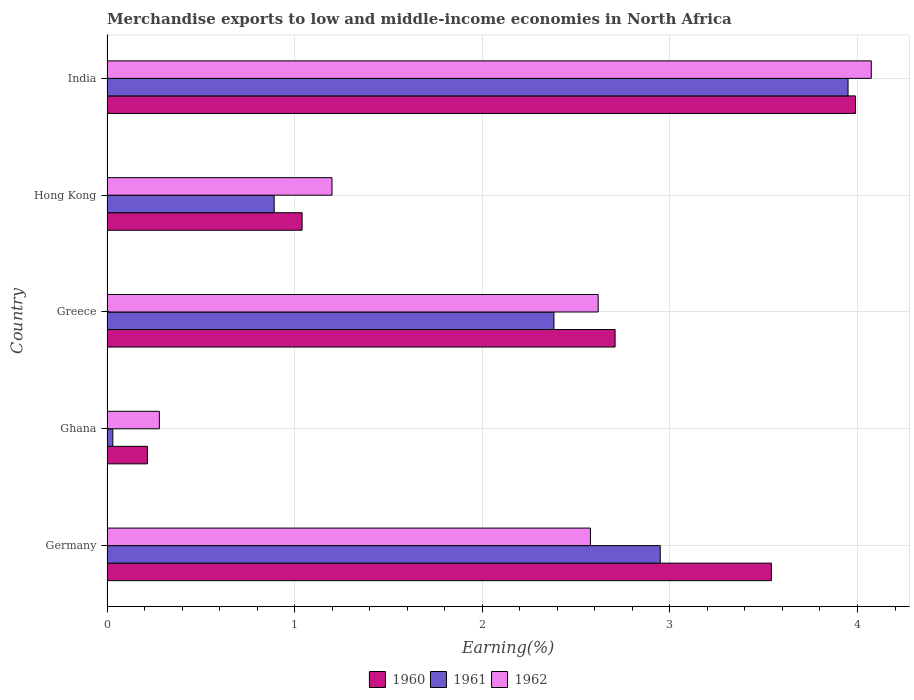How many different coloured bars are there?
Offer a very short reply. 3. What is the percentage of amount earned from merchandise exports in 1962 in India?
Ensure brevity in your answer.  4.07. Across all countries, what is the maximum percentage of amount earned from merchandise exports in 1960?
Keep it short and to the point. 3.99. Across all countries, what is the minimum percentage of amount earned from merchandise exports in 1960?
Make the answer very short. 0.22. In which country was the percentage of amount earned from merchandise exports in 1962 maximum?
Your response must be concise. India. In which country was the percentage of amount earned from merchandise exports in 1961 minimum?
Your answer should be compact. Ghana. What is the total percentage of amount earned from merchandise exports in 1961 in the graph?
Make the answer very short. 10.2. What is the difference between the percentage of amount earned from merchandise exports in 1960 in Germany and that in Greece?
Provide a short and direct response. 0.83. What is the difference between the percentage of amount earned from merchandise exports in 1960 in Greece and the percentage of amount earned from merchandise exports in 1961 in India?
Offer a terse response. -1.24. What is the average percentage of amount earned from merchandise exports in 1962 per country?
Your answer should be compact. 2.15. What is the difference between the percentage of amount earned from merchandise exports in 1960 and percentage of amount earned from merchandise exports in 1962 in Greece?
Your answer should be compact. 0.09. What is the ratio of the percentage of amount earned from merchandise exports in 1960 in Ghana to that in Greece?
Give a very brief answer. 0.08. What is the difference between the highest and the second highest percentage of amount earned from merchandise exports in 1960?
Make the answer very short. 0.45. What is the difference between the highest and the lowest percentage of amount earned from merchandise exports in 1961?
Make the answer very short. 3.92. Is the sum of the percentage of amount earned from merchandise exports in 1962 in Ghana and Greece greater than the maximum percentage of amount earned from merchandise exports in 1960 across all countries?
Make the answer very short. No. Are all the bars in the graph horizontal?
Make the answer very short. Yes. What is the difference between two consecutive major ticks on the X-axis?
Your response must be concise. 1. Are the values on the major ticks of X-axis written in scientific E-notation?
Provide a succinct answer. No. Where does the legend appear in the graph?
Your answer should be compact. Bottom center. How many legend labels are there?
Your answer should be compact. 3. How are the legend labels stacked?
Offer a very short reply. Horizontal. What is the title of the graph?
Give a very brief answer. Merchandise exports to low and middle-income economies in North Africa. What is the label or title of the X-axis?
Your response must be concise. Earning(%). What is the label or title of the Y-axis?
Make the answer very short. Country. What is the Earning(%) of 1960 in Germany?
Ensure brevity in your answer.  3.54. What is the Earning(%) of 1961 in Germany?
Keep it short and to the point. 2.95. What is the Earning(%) of 1962 in Germany?
Provide a short and direct response. 2.58. What is the Earning(%) in 1960 in Ghana?
Ensure brevity in your answer.  0.22. What is the Earning(%) of 1961 in Ghana?
Offer a terse response. 0.03. What is the Earning(%) of 1962 in Ghana?
Make the answer very short. 0.28. What is the Earning(%) in 1960 in Greece?
Ensure brevity in your answer.  2.71. What is the Earning(%) in 1961 in Greece?
Give a very brief answer. 2.38. What is the Earning(%) of 1962 in Greece?
Offer a very short reply. 2.62. What is the Earning(%) in 1960 in Hong Kong?
Provide a short and direct response. 1.04. What is the Earning(%) in 1961 in Hong Kong?
Offer a very short reply. 0.89. What is the Earning(%) of 1962 in Hong Kong?
Keep it short and to the point. 1.2. What is the Earning(%) in 1960 in India?
Your answer should be compact. 3.99. What is the Earning(%) of 1961 in India?
Your response must be concise. 3.95. What is the Earning(%) in 1962 in India?
Provide a short and direct response. 4.07. Across all countries, what is the maximum Earning(%) of 1960?
Ensure brevity in your answer.  3.99. Across all countries, what is the maximum Earning(%) in 1961?
Provide a succinct answer. 3.95. Across all countries, what is the maximum Earning(%) of 1962?
Offer a terse response. 4.07. Across all countries, what is the minimum Earning(%) of 1960?
Give a very brief answer. 0.22. Across all countries, what is the minimum Earning(%) of 1961?
Keep it short and to the point. 0.03. Across all countries, what is the minimum Earning(%) in 1962?
Give a very brief answer. 0.28. What is the total Earning(%) in 1960 in the graph?
Offer a very short reply. 11.49. What is the total Earning(%) of 1961 in the graph?
Your answer should be very brief. 10.2. What is the total Earning(%) in 1962 in the graph?
Offer a terse response. 10.75. What is the difference between the Earning(%) in 1960 in Germany and that in Ghana?
Offer a terse response. 3.33. What is the difference between the Earning(%) in 1961 in Germany and that in Ghana?
Provide a short and direct response. 2.92. What is the difference between the Earning(%) in 1962 in Germany and that in Ghana?
Keep it short and to the point. 2.3. What is the difference between the Earning(%) in 1960 in Germany and that in Greece?
Your answer should be very brief. 0.83. What is the difference between the Earning(%) of 1961 in Germany and that in Greece?
Provide a short and direct response. 0.57. What is the difference between the Earning(%) in 1962 in Germany and that in Greece?
Provide a succinct answer. -0.04. What is the difference between the Earning(%) in 1960 in Germany and that in Hong Kong?
Offer a terse response. 2.5. What is the difference between the Earning(%) in 1961 in Germany and that in Hong Kong?
Your response must be concise. 2.06. What is the difference between the Earning(%) in 1962 in Germany and that in Hong Kong?
Make the answer very short. 1.38. What is the difference between the Earning(%) of 1960 in Germany and that in India?
Offer a very short reply. -0.45. What is the difference between the Earning(%) in 1961 in Germany and that in India?
Make the answer very short. -1. What is the difference between the Earning(%) of 1962 in Germany and that in India?
Your answer should be very brief. -1.5. What is the difference between the Earning(%) of 1960 in Ghana and that in Greece?
Offer a terse response. -2.49. What is the difference between the Earning(%) in 1961 in Ghana and that in Greece?
Keep it short and to the point. -2.35. What is the difference between the Earning(%) in 1962 in Ghana and that in Greece?
Offer a very short reply. -2.34. What is the difference between the Earning(%) in 1960 in Ghana and that in Hong Kong?
Provide a short and direct response. -0.82. What is the difference between the Earning(%) of 1961 in Ghana and that in Hong Kong?
Your answer should be very brief. -0.86. What is the difference between the Earning(%) of 1962 in Ghana and that in Hong Kong?
Make the answer very short. -0.92. What is the difference between the Earning(%) of 1960 in Ghana and that in India?
Give a very brief answer. -3.77. What is the difference between the Earning(%) of 1961 in Ghana and that in India?
Provide a succinct answer. -3.92. What is the difference between the Earning(%) of 1962 in Ghana and that in India?
Provide a succinct answer. -3.79. What is the difference between the Earning(%) of 1960 in Greece and that in Hong Kong?
Make the answer very short. 1.67. What is the difference between the Earning(%) of 1961 in Greece and that in Hong Kong?
Your response must be concise. 1.49. What is the difference between the Earning(%) of 1962 in Greece and that in Hong Kong?
Offer a terse response. 1.42. What is the difference between the Earning(%) in 1960 in Greece and that in India?
Offer a very short reply. -1.28. What is the difference between the Earning(%) of 1961 in Greece and that in India?
Provide a short and direct response. -1.57. What is the difference between the Earning(%) in 1962 in Greece and that in India?
Your response must be concise. -1.46. What is the difference between the Earning(%) of 1960 in Hong Kong and that in India?
Your answer should be very brief. -2.95. What is the difference between the Earning(%) of 1961 in Hong Kong and that in India?
Your answer should be compact. -3.06. What is the difference between the Earning(%) in 1962 in Hong Kong and that in India?
Offer a terse response. -2.87. What is the difference between the Earning(%) of 1960 in Germany and the Earning(%) of 1961 in Ghana?
Your answer should be compact. 3.51. What is the difference between the Earning(%) of 1960 in Germany and the Earning(%) of 1962 in Ghana?
Ensure brevity in your answer.  3.26. What is the difference between the Earning(%) of 1961 in Germany and the Earning(%) of 1962 in Ghana?
Offer a terse response. 2.67. What is the difference between the Earning(%) in 1960 in Germany and the Earning(%) in 1961 in Greece?
Make the answer very short. 1.16. What is the difference between the Earning(%) in 1960 in Germany and the Earning(%) in 1962 in Greece?
Offer a very short reply. 0.92. What is the difference between the Earning(%) of 1961 in Germany and the Earning(%) of 1962 in Greece?
Make the answer very short. 0.33. What is the difference between the Earning(%) of 1960 in Germany and the Earning(%) of 1961 in Hong Kong?
Make the answer very short. 2.65. What is the difference between the Earning(%) of 1960 in Germany and the Earning(%) of 1962 in Hong Kong?
Provide a succinct answer. 2.34. What is the difference between the Earning(%) of 1961 in Germany and the Earning(%) of 1962 in Hong Kong?
Your answer should be very brief. 1.75. What is the difference between the Earning(%) of 1960 in Germany and the Earning(%) of 1961 in India?
Your response must be concise. -0.41. What is the difference between the Earning(%) in 1960 in Germany and the Earning(%) in 1962 in India?
Offer a terse response. -0.53. What is the difference between the Earning(%) in 1961 in Germany and the Earning(%) in 1962 in India?
Keep it short and to the point. -1.12. What is the difference between the Earning(%) of 1960 in Ghana and the Earning(%) of 1961 in Greece?
Keep it short and to the point. -2.17. What is the difference between the Earning(%) in 1960 in Ghana and the Earning(%) in 1962 in Greece?
Offer a very short reply. -2.4. What is the difference between the Earning(%) in 1961 in Ghana and the Earning(%) in 1962 in Greece?
Provide a short and direct response. -2.59. What is the difference between the Earning(%) of 1960 in Ghana and the Earning(%) of 1961 in Hong Kong?
Your answer should be compact. -0.68. What is the difference between the Earning(%) of 1960 in Ghana and the Earning(%) of 1962 in Hong Kong?
Provide a succinct answer. -0.98. What is the difference between the Earning(%) in 1961 in Ghana and the Earning(%) in 1962 in Hong Kong?
Ensure brevity in your answer.  -1.17. What is the difference between the Earning(%) in 1960 in Ghana and the Earning(%) in 1961 in India?
Provide a succinct answer. -3.73. What is the difference between the Earning(%) of 1960 in Ghana and the Earning(%) of 1962 in India?
Provide a succinct answer. -3.86. What is the difference between the Earning(%) of 1961 in Ghana and the Earning(%) of 1962 in India?
Keep it short and to the point. -4.04. What is the difference between the Earning(%) of 1960 in Greece and the Earning(%) of 1961 in Hong Kong?
Ensure brevity in your answer.  1.82. What is the difference between the Earning(%) in 1960 in Greece and the Earning(%) in 1962 in Hong Kong?
Provide a succinct answer. 1.51. What is the difference between the Earning(%) in 1961 in Greece and the Earning(%) in 1962 in Hong Kong?
Provide a succinct answer. 1.18. What is the difference between the Earning(%) in 1960 in Greece and the Earning(%) in 1961 in India?
Offer a terse response. -1.24. What is the difference between the Earning(%) of 1960 in Greece and the Earning(%) of 1962 in India?
Your response must be concise. -1.37. What is the difference between the Earning(%) in 1961 in Greece and the Earning(%) in 1962 in India?
Your answer should be very brief. -1.69. What is the difference between the Earning(%) in 1960 in Hong Kong and the Earning(%) in 1961 in India?
Your response must be concise. -2.91. What is the difference between the Earning(%) of 1960 in Hong Kong and the Earning(%) of 1962 in India?
Your response must be concise. -3.03. What is the difference between the Earning(%) in 1961 in Hong Kong and the Earning(%) in 1962 in India?
Offer a very short reply. -3.18. What is the average Earning(%) in 1960 per country?
Your response must be concise. 2.3. What is the average Earning(%) in 1961 per country?
Keep it short and to the point. 2.04. What is the average Earning(%) of 1962 per country?
Ensure brevity in your answer.  2.15. What is the difference between the Earning(%) of 1960 and Earning(%) of 1961 in Germany?
Make the answer very short. 0.59. What is the difference between the Earning(%) of 1960 and Earning(%) of 1962 in Germany?
Keep it short and to the point. 0.96. What is the difference between the Earning(%) in 1961 and Earning(%) in 1962 in Germany?
Your answer should be compact. 0.37. What is the difference between the Earning(%) of 1960 and Earning(%) of 1961 in Ghana?
Your answer should be very brief. 0.18. What is the difference between the Earning(%) of 1960 and Earning(%) of 1962 in Ghana?
Offer a terse response. -0.06. What is the difference between the Earning(%) of 1961 and Earning(%) of 1962 in Ghana?
Provide a succinct answer. -0.25. What is the difference between the Earning(%) of 1960 and Earning(%) of 1961 in Greece?
Ensure brevity in your answer.  0.33. What is the difference between the Earning(%) of 1960 and Earning(%) of 1962 in Greece?
Offer a terse response. 0.09. What is the difference between the Earning(%) of 1961 and Earning(%) of 1962 in Greece?
Provide a short and direct response. -0.24. What is the difference between the Earning(%) of 1960 and Earning(%) of 1961 in Hong Kong?
Provide a short and direct response. 0.15. What is the difference between the Earning(%) in 1960 and Earning(%) in 1962 in Hong Kong?
Give a very brief answer. -0.16. What is the difference between the Earning(%) in 1961 and Earning(%) in 1962 in Hong Kong?
Offer a very short reply. -0.31. What is the difference between the Earning(%) of 1960 and Earning(%) of 1961 in India?
Make the answer very short. 0.04. What is the difference between the Earning(%) of 1960 and Earning(%) of 1962 in India?
Offer a terse response. -0.08. What is the difference between the Earning(%) in 1961 and Earning(%) in 1962 in India?
Provide a succinct answer. -0.12. What is the ratio of the Earning(%) of 1960 in Germany to that in Ghana?
Your answer should be very brief. 16.45. What is the ratio of the Earning(%) of 1961 in Germany to that in Ghana?
Your answer should be compact. 95.03. What is the ratio of the Earning(%) in 1962 in Germany to that in Ghana?
Make the answer very short. 9.24. What is the ratio of the Earning(%) of 1960 in Germany to that in Greece?
Offer a very short reply. 1.31. What is the ratio of the Earning(%) in 1961 in Germany to that in Greece?
Ensure brevity in your answer.  1.24. What is the ratio of the Earning(%) in 1962 in Germany to that in Greece?
Your response must be concise. 0.98. What is the ratio of the Earning(%) in 1960 in Germany to that in Hong Kong?
Your answer should be very brief. 3.41. What is the ratio of the Earning(%) of 1961 in Germany to that in Hong Kong?
Provide a succinct answer. 3.31. What is the ratio of the Earning(%) in 1962 in Germany to that in Hong Kong?
Keep it short and to the point. 2.15. What is the ratio of the Earning(%) in 1960 in Germany to that in India?
Ensure brevity in your answer.  0.89. What is the ratio of the Earning(%) in 1961 in Germany to that in India?
Your answer should be very brief. 0.75. What is the ratio of the Earning(%) in 1962 in Germany to that in India?
Offer a terse response. 0.63. What is the ratio of the Earning(%) of 1960 in Ghana to that in Greece?
Ensure brevity in your answer.  0.08. What is the ratio of the Earning(%) in 1961 in Ghana to that in Greece?
Offer a very short reply. 0.01. What is the ratio of the Earning(%) of 1962 in Ghana to that in Greece?
Your response must be concise. 0.11. What is the ratio of the Earning(%) in 1960 in Ghana to that in Hong Kong?
Give a very brief answer. 0.21. What is the ratio of the Earning(%) of 1961 in Ghana to that in Hong Kong?
Ensure brevity in your answer.  0.03. What is the ratio of the Earning(%) in 1962 in Ghana to that in Hong Kong?
Make the answer very short. 0.23. What is the ratio of the Earning(%) in 1960 in Ghana to that in India?
Keep it short and to the point. 0.05. What is the ratio of the Earning(%) of 1961 in Ghana to that in India?
Provide a succinct answer. 0.01. What is the ratio of the Earning(%) of 1962 in Ghana to that in India?
Provide a short and direct response. 0.07. What is the ratio of the Earning(%) of 1960 in Greece to that in Hong Kong?
Make the answer very short. 2.6. What is the ratio of the Earning(%) in 1961 in Greece to that in Hong Kong?
Provide a succinct answer. 2.67. What is the ratio of the Earning(%) in 1962 in Greece to that in Hong Kong?
Offer a terse response. 2.18. What is the ratio of the Earning(%) in 1960 in Greece to that in India?
Make the answer very short. 0.68. What is the ratio of the Earning(%) in 1961 in Greece to that in India?
Make the answer very short. 0.6. What is the ratio of the Earning(%) in 1962 in Greece to that in India?
Your answer should be compact. 0.64. What is the ratio of the Earning(%) in 1960 in Hong Kong to that in India?
Offer a very short reply. 0.26. What is the ratio of the Earning(%) in 1961 in Hong Kong to that in India?
Your response must be concise. 0.23. What is the ratio of the Earning(%) of 1962 in Hong Kong to that in India?
Offer a very short reply. 0.29. What is the difference between the highest and the second highest Earning(%) in 1960?
Offer a terse response. 0.45. What is the difference between the highest and the second highest Earning(%) of 1962?
Offer a terse response. 1.46. What is the difference between the highest and the lowest Earning(%) in 1960?
Provide a succinct answer. 3.77. What is the difference between the highest and the lowest Earning(%) of 1961?
Give a very brief answer. 3.92. What is the difference between the highest and the lowest Earning(%) of 1962?
Offer a terse response. 3.79. 